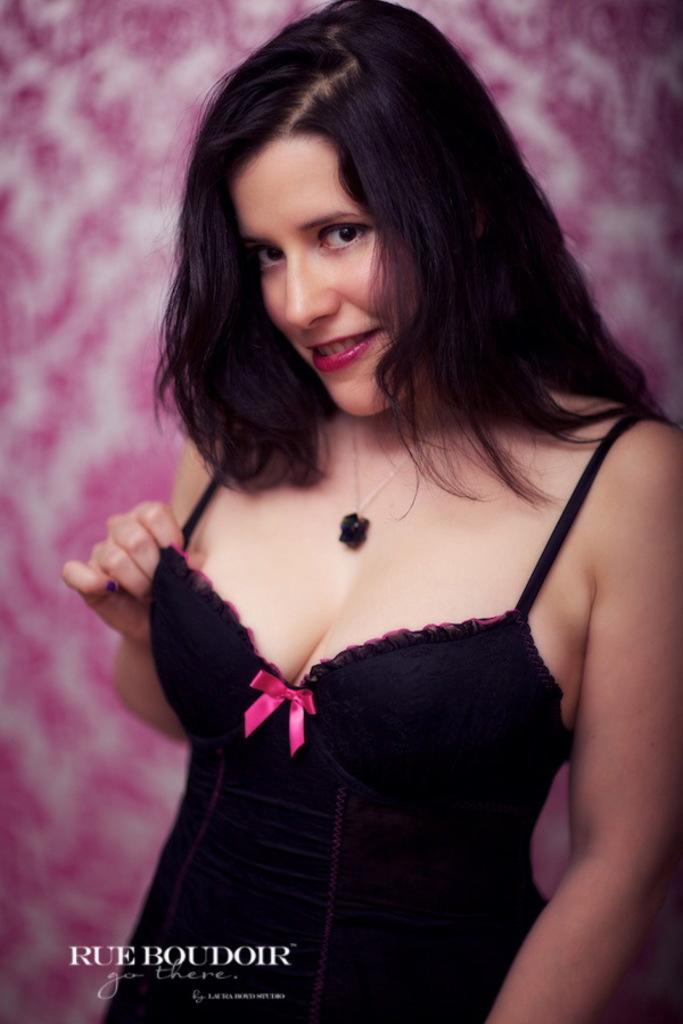Could you give a brief overview of what you see in this image? In this image there is a woman standing and smiling and the background is blurry and at the bottom of the image there is some text written on it. 